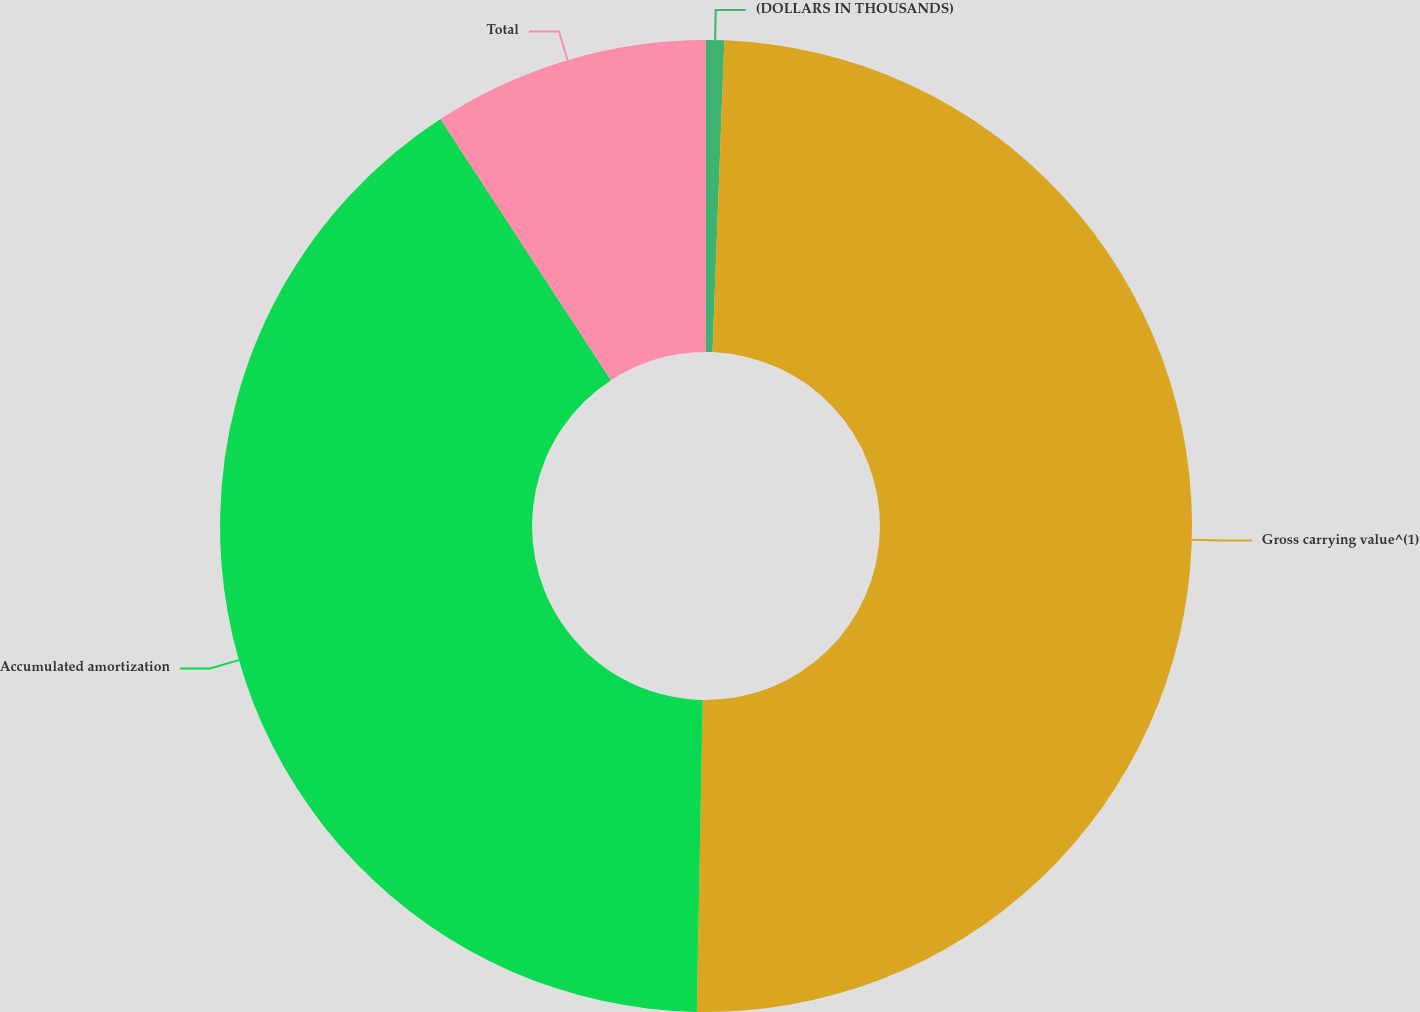Convert chart to OTSL. <chart><loc_0><loc_0><loc_500><loc_500><pie_chart><fcel>(DOLLARS IN THOUSANDS)<fcel>Gross carrying value^(1)<fcel>Accumulated amortization<fcel>Total<nl><fcel>0.6%<fcel>49.7%<fcel>40.5%<fcel>9.2%<nl></chart> 